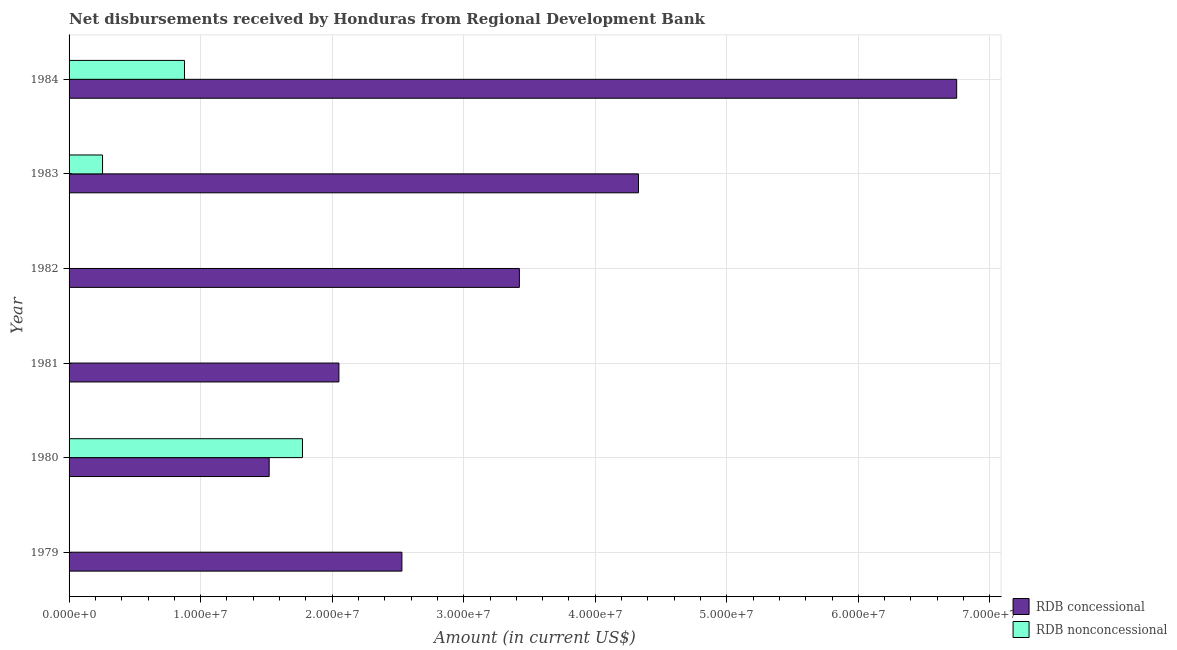How many different coloured bars are there?
Your answer should be very brief. 2. Are the number of bars on each tick of the Y-axis equal?
Offer a very short reply. No. In how many cases, is the number of bars for a given year not equal to the number of legend labels?
Your response must be concise. 3. What is the net concessional disbursements from rdb in 1980?
Provide a succinct answer. 1.52e+07. Across all years, what is the maximum net non concessional disbursements from rdb?
Your answer should be compact. 1.77e+07. Across all years, what is the minimum net concessional disbursements from rdb?
Offer a very short reply. 1.52e+07. What is the total net concessional disbursements from rdb in the graph?
Ensure brevity in your answer.  2.06e+08. What is the difference between the net concessional disbursements from rdb in 1981 and that in 1982?
Ensure brevity in your answer.  -1.37e+07. What is the difference between the net concessional disbursements from rdb in 1984 and the net non concessional disbursements from rdb in 1979?
Provide a short and direct response. 6.75e+07. What is the average net non concessional disbursements from rdb per year?
Keep it short and to the point. 4.84e+06. In the year 1983, what is the difference between the net concessional disbursements from rdb and net non concessional disbursements from rdb?
Offer a terse response. 4.07e+07. What is the ratio of the net concessional disbursements from rdb in 1982 to that in 1984?
Your answer should be very brief. 0.51. What is the difference between the highest and the second highest net concessional disbursements from rdb?
Your answer should be compact. 2.42e+07. What is the difference between the highest and the lowest net concessional disbursements from rdb?
Provide a short and direct response. 5.23e+07. How many years are there in the graph?
Make the answer very short. 6. Are the values on the major ticks of X-axis written in scientific E-notation?
Give a very brief answer. Yes. Does the graph contain any zero values?
Your response must be concise. Yes. How many legend labels are there?
Your response must be concise. 2. What is the title of the graph?
Keep it short and to the point. Net disbursements received by Honduras from Regional Development Bank. Does "Ages 15-24" appear as one of the legend labels in the graph?
Your answer should be compact. No. What is the label or title of the Y-axis?
Ensure brevity in your answer.  Year. What is the Amount (in current US$) in RDB concessional in 1979?
Make the answer very short. 2.53e+07. What is the Amount (in current US$) in RDB nonconcessional in 1979?
Provide a short and direct response. 0. What is the Amount (in current US$) of RDB concessional in 1980?
Make the answer very short. 1.52e+07. What is the Amount (in current US$) in RDB nonconcessional in 1980?
Your answer should be compact. 1.77e+07. What is the Amount (in current US$) of RDB concessional in 1981?
Offer a very short reply. 2.05e+07. What is the Amount (in current US$) of RDB nonconcessional in 1981?
Provide a succinct answer. 0. What is the Amount (in current US$) of RDB concessional in 1982?
Keep it short and to the point. 3.42e+07. What is the Amount (in current US$) of RDB nonconcessional in 1982?
Your answer should be compact. 0. What is the Amount (in current US$) of RDB concessional in 1983?
Your answer should be very brief. 4.33e+07. What is the Amount (in current US$) of RDB nonconcessional in 1983?
Provide a short and direct response. 2.54e+06. What is the Amount (in current US$) of RDB concessional in 1984?
Ensure brevity in your answer.  6.75e+07. What is the Amount (in current US$) of RDB nonconcessional in 1984?
Your answer should be very brief. 8.77e+06. Across all years, what is the maximum Amount (in current US$) of RDB concessional?
Your answer should be very brief. 6.75e+07. Across all years, what is the maximum Amount (in current US$) in RDB nonconcessional?
Make the answer very short. 1.77e+07. Across all years, what is the minimum Amount (in current US$) in RDB concessional?
Provide a succinct answer. 1.52e+07. What is the total Amount (in current US$) in RDB concessional in the graph?
Give a very brief answer. 2.06e+08. What is the total Amount (in current US$) in RDB nonconcessional in the graph?
Offer a terse response. 2.91e+07. What is the difference between the Amount (in current US$) of RDB concessional in 1979 and that in 1980?
Your response must be concise. 1.01e+07. What is the difference between the Amount (in current US$) in RDB concessional in 1979 and that in 1981?
Your answer should be compact. 4.79e+06. What is the difference between the Amount (in current US$) in RDB concessional in 1979 and that in 1982?
Ensure brevity in your answer.  -8.93e+06. What is the difference between the Amount (in current US$) in RDB concessional in 1979 and that in 1983?
Your answer should be very brief. -1.80e+07. What is the difference between the Amount (in current US$) of RDB concessional in 1979 and that in 1984?
Give a very brief answer. -4.22e+07. What is the difference between the Amount (in current US$) of RDB concessional in 1980 and that in 1981?
Your answer should be very brief. -5.30e+06. What is the difference between the Amount (in current US$) in RDB concessional in 1980 and that in 1982?
Your response must be concise. -1.90e+07. What is the difference between the Amount (in current US$) of RDB concessional in 1980 and that in 1983?
Your answer should be very brief. -2.81e+07. What is the difference between the Amount (in current US$) in RDB nonconcessional in 1980 and that in 1983?
Offer a very short reply. 1.52e+07. What is the difference between the Amount (in current US$) of RDB concessional in 1980 and that in 1984?
Your answer should be compact. -5.23e+07. What is the difference between the Amount (in current US$) of RDB nonconcessional in 1980 and that in 1984?
Provide a succinct answer. 8.97e+06. What is the difference between the Amount (in current US$) of RDB concessional in 1981 and that in 1982?
Your response must be concise. -1.37e+07. What is the difference between the Amount (in current US$) of RDB concessional in 1981 and that in 1983?
Ensure brevity in your answer.  -2.28e+07. What is the difference between the Amount (in current US$) of RDB concessional in 1981 and that in 1984?
Keep it short and to the point. -4.70e+07. What is the difference between the Amount (in current US$) of RDB concessional in 1982 and that in 1983?
Ensure brevity in your answer.  -9.05e+06. What is the difference between the Amount (in current US$) of RDB concessional in 1982 and that in 1984?
Your answer should be compact. -3.32e+07. What is the difference between the Amount (in current US$) in RDB concessional in 1983 and that in 1984?
Your answer should be compact. -2.42e+07. What is the difference between the Amount (in current US$) of RDB nonconcessional in 1983 and that in 1984?
Ensure brevity in your answer.  -6.23e+06. What is the difference between the Amount (in current US$) in RDB concessional in 1979 and the Amount (in current US$) in RDB nonconcessional in 1980?
Provide a short and direct response. 7.56e+06. What is the difference between the Amount (in current US$) in RDB concessional in 1979 and the Amount (in current US$) in RDB nonconcessional in 1983?
Offer a very short reply. 2.28e+07. What is the difference between the Amount (in current US$) in RDB concessional in 1979 and the Amount (in current US$) in RDB nonconcessional in 1984?
Offer a very short reply. 1.65e+07. What is the difference between the Amount (in current US$) of RDB concessional in 1980 and the Amount (in current US$) of RDB nonconcessional in 1983?
Make the answer very short. 1.27e+07. What is the difference between the Amount (in current US$) in RDB concessional in 1980 and the Amount (in current US$) in RDB nonconcessional in 1984?
Give a very brief answer. 6.44e+06. What is the difference between the Amount (in current US$) in RDB concessional in 1981 and the Amount (in current US$) in RDB nonconcessional in 1983?
Provide a succinct answer. 1.80e+07. What is the difference between the Amount (in current US$) of RDB concessional in 1981 and the Amount (in current US$) of RDB nonconcessional in 1984?
Ensure brevity in your answer.  1.17e+07. What is the difference between the Amount (in current US$) in RDB concessional in 1982 and the Amount (in current US$) in RDB nonconcessional in 1983?
Your answer should be compact. 3.17e+07. What is the difference between the Amount (in current US$) in RDB concessional in 1982 and the Amount (in current US$) in RDB nonconcessional in 1984?
Ensure brevity in your answer.  2.55e+07. What is the difference between the Amount (in current US$) in RDB concessional in 1983 and the Amount (in current US$) in RDB nonconcessional in 1984?
Your answer should be compact. 3.45e+07. What is the average Amount (in current US$) of RDB concessional per year?
Ensure brevity in your answer.  3.43e+07. What is the average Amount (in current US$) in RDB nonconcessional per year?
Provide a short and direct response. 4.84e+06. In the year 1980, what is the difference between the Amount (in current US$) in RDB concessional and Amount (in current US$) in RDB nonconcessional?
Provide a succinct answer. -2.53e+06. In the year 1983, what is the difference between the Amount (in current US$) of RDB concessional and Amount (in current US$) of RDB nonconcessional?
Your answer should be very brief. 4.07e+07. In the year 1984, what is the difference between the Amount (in current US$) of RDB concessional and Amount (in current US$) of RDB nonconcessional?
Provide a short and direct response. 5.87e+07. What is the ratio of the Amount (in current US$) in RDB concessional in 1979 to that in 1980?
Make the answer very short. 1.66. What is the ratio of the Amount (in current US$) in RDB concessional in 1979 to that in 1981?
Provide a succinct answer. 1.23. What is the ratio of the Amount (in current US$) in RDB concessional in 1979 to that in 1982?
Provide a short and direct response. 0.74. What is the ratio of the Amount (in current US$) in RDB concessional in 1979 to that in 1983?
Your answer should be very brief. 0.58. What is the ratio of the Amount (in current US$) of RDB concessional in 1979 to that in 1984?
Ensure brevity in your answer.  0.38. What is the ratio of the Amount (in current US$) of RDB concessional in 1980 to that in 1981?
Provide a succinct answer. 0.74. What is the ratio of the Amount (in current US$) of RDB concessional in 1980 to that in 1982?
Your answer should be compact. 0.44. What is the ratio of the Amount (in current US$) in RDB concessional in 1980 to that in 1983?
Your answer should be very brief. 0.35. What is the ratio of the Amount (in current US$) in RDB nonconcessional in 1980 to that in 1983?
Your response must be concise. 6.97. What is the ratio of the Amount (in current US$) of RDB concessional in 1980 to that in 1984?
Your response must be concise. 0.23. What is the ratio of the Amount (in current US$) in RDB nonconcessional in 1980 to that in 1984?
Your response must be concise. 2.02. What is the ratio of the Amount (in current US$) of RDB concessional in 1981 to that in 1982?
Your response must be concise. 0.6. What is the ratio of the Amount (in current US$) in RDB concessional in 1981 to that in 1983?
Your answer should be compact. 0.47. What is the ratio of the Amount (in current US$) in RDB concessional in 1981 to that in 1984?
Ensure brevity in your answer.  0.3. What is the ratio of the Amount (in current US$) of RDB concessional in 1982 to that in 1983?
Make the answer very short. 0.79. What is the ratio of the Amount (in current US$) in RDB concessional in 1982 to that in 1984?
Provide a succinct answer. 0.51. What is the ratio of the Amount (in current US$) of RDB concessional in 1983 to that in 1984?
Give a very brief answer. 0.64. What is the ratio of the Amount (in current US$) in RDB nonconcessional in 1983 to that in 1984?
Offer a terse response. 0.29. What is the difference between the highest and the second highest Amount (in current US$) of RDB concessional?
Make the answer very short. 2.42e+07. What is the difference between the highest and the second highest Amount (in current US$) of RDB nonconcessional?
Provide a short and direct response. 8.97e+06. What is the difference between the highest and the lowest Amount (in current US$) of RDB concessional?
Keep it short and to the point. 5.23e+07. What is the difference between the highest and the lowest Amount (in current US$) of RDB nonconcessional?
Your response must be concise. 1.77e+07. 